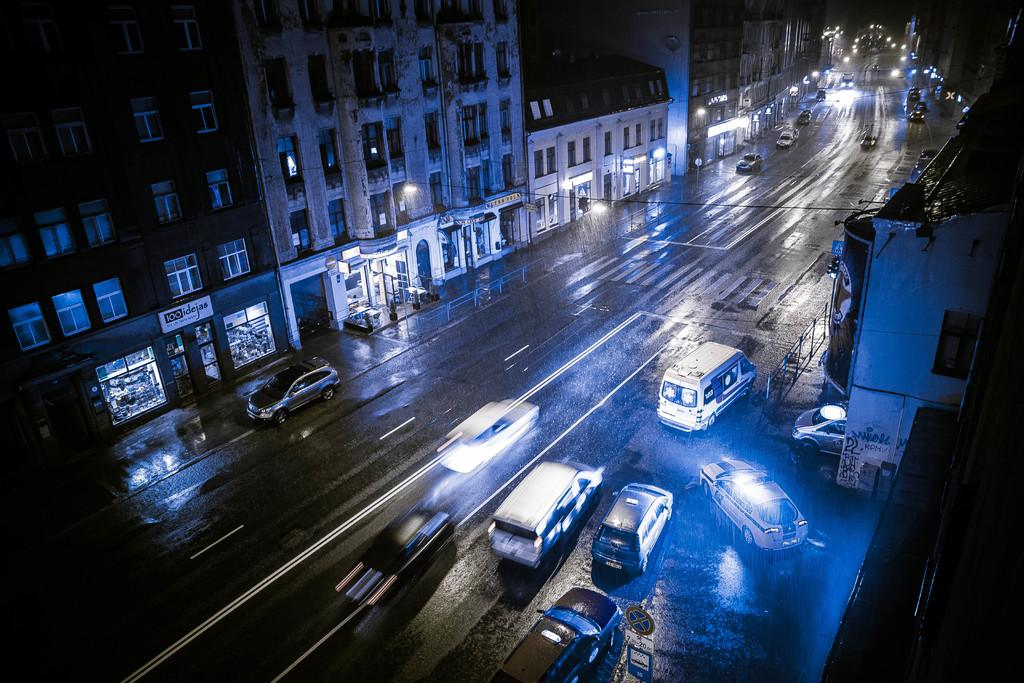What can be seen on the road in the image? There are vehicles on the road in the image. What is visible on both sides of the road? There are buildings on both sides of the road. How would you describe the background of the image? The background of the image is dark in color. Can you see a notebook on the roof of one of the buildings in the image? There is no notebook visible on the roof of any building in the image. Is there a train passing by in the image? There is no train present in the image; only vehicles on the road are visible. 